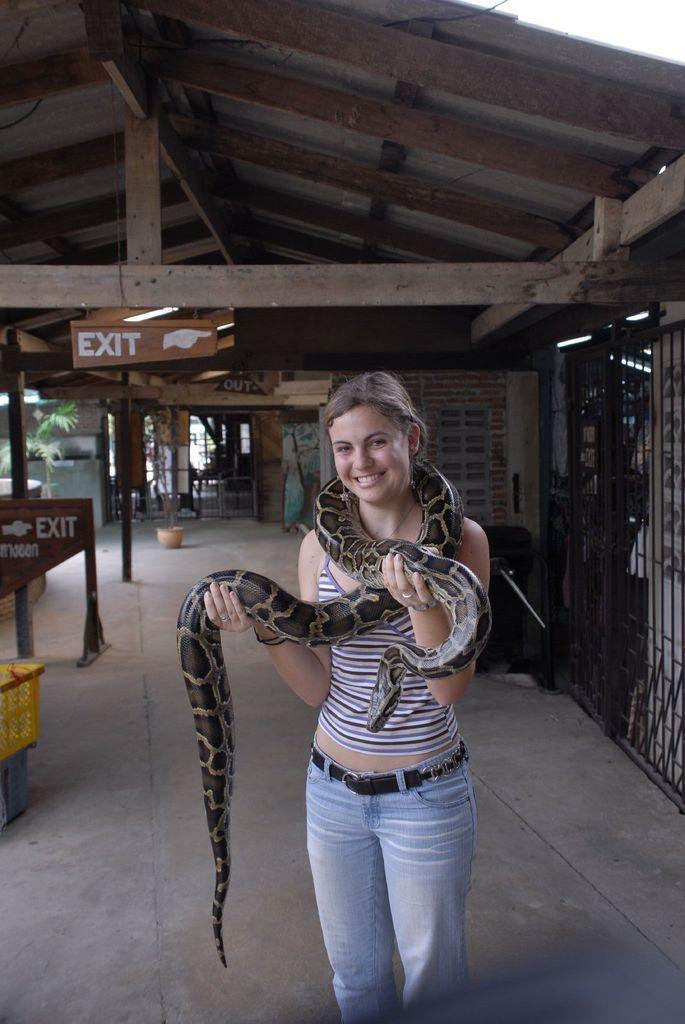Please provide a concise description of this image. In this image I can see a woman holding a snake she is smiling, standing on the floor in the foreground visible under the wooden tent there are some sign boards visible on the left side and there is a fence on the right side, there is a flower pot , plant visible in the middle there are two boxes kept on floor on the left side. 